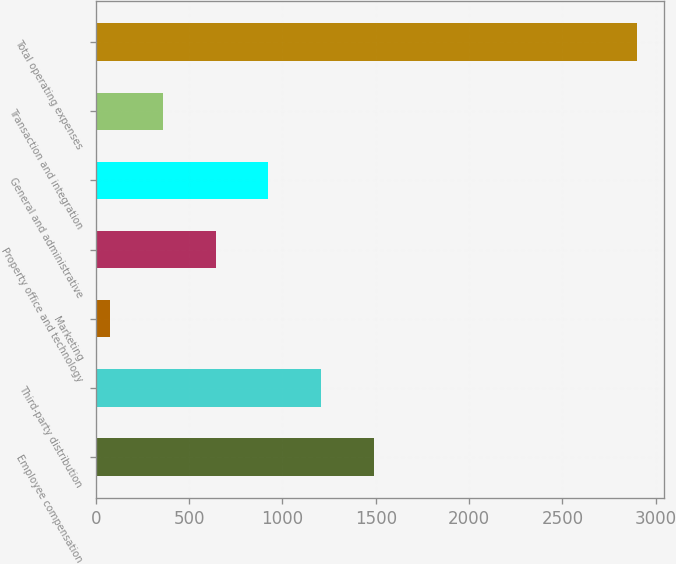Convert chart. <chart><loc_0><loc_0><loc_500><loc_500><bar_chart><fcel>Employee compensation<fcel>Third-party distribution<fcel>Marketing<fcel>Property office and technology<fcel>General and administrative<fcel>Transaction and integration<fcel>Total operating expenses<nl><fcel>1488.15<fcel>1206.22<fcel>78.5<fcel>642.36<fcel>924.29<fcel>360.43<fcel>2897.8<nl></chart> 